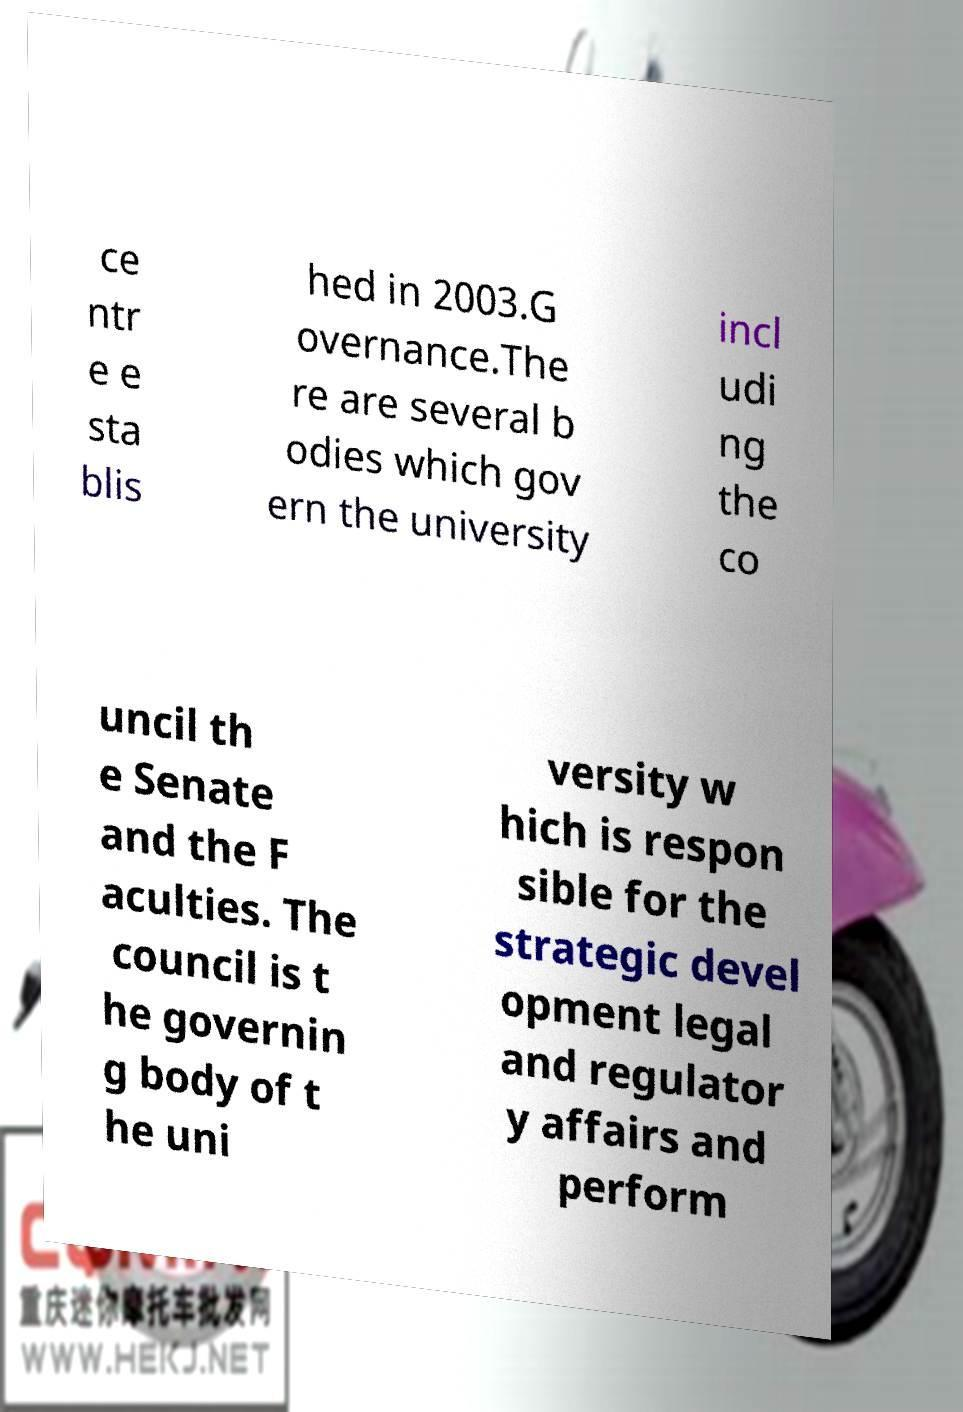For documentation purposes, I need the text within this image transcribed. Could you provide that? ce ntr e e sta blis hed in 2003.G overnance.The re are several b odies which gov ern the university incl udi ng the co uncil th e Senate and the F aculties. The council is t he governin g body of t he uni versity w hich is respon sible for the strategic devel opment legal and regulator y affairs and perform 